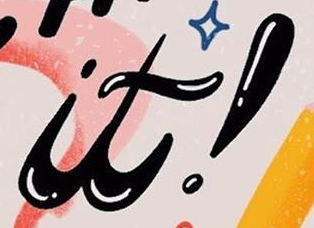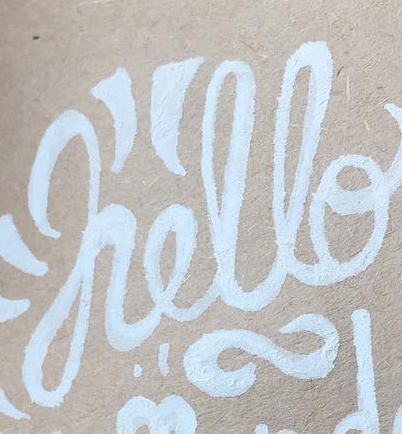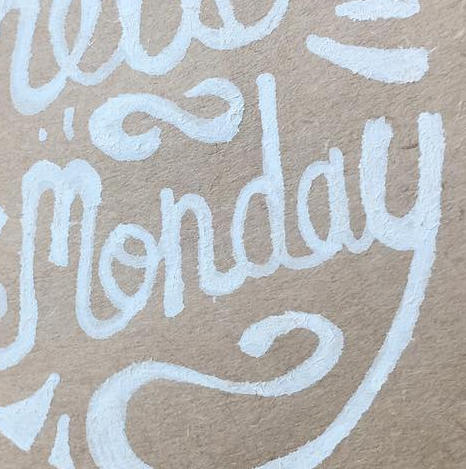What words can you see in these images in sequence, separated by a semicolon? it!; hello; monday 